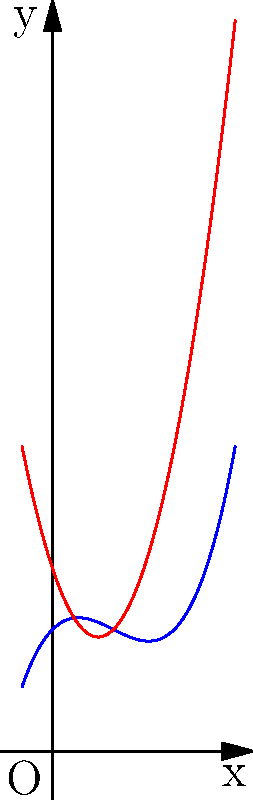The curves above represent the cross-sectional shapes of two different medicinal plant seeds. Seed A is represented by the blue curve, and Seed B is represented by the red curve. At which point(s) do these seeds have the same curvature? To find the point(s) where the seeds have the same curvature, we need to follow these steps:

1. Identify the functions representing each seed:
   Seed A (blue): $f(x) = 0.5x^3 - 1.5x^2 + x + 2$
   Seed B (red): $g(x) = 2x^2 - 3x + 3$

2. Calculate the second derivatives of both functions:
   $f''(x) = 3x - 3$
   $g''(x) = 4$

3. The curvature is the same when the second derivatives are equal:
   $f''(x) = g''(x)$
   $3x - 3 = 4$

4. Solve the equation:
   $3x - 3 = 4$
   $3x = 7$
   $x = \frac{7}{3}$

5. Verify the solution:
   At $x = \frac{7}{3}$, both functions have a second derivative equal to 4.

Therefore, the seeds have the same curvature at the point where $x = \frac{7}{3}$.
Answer: $x = \frac{7}{3}$ 